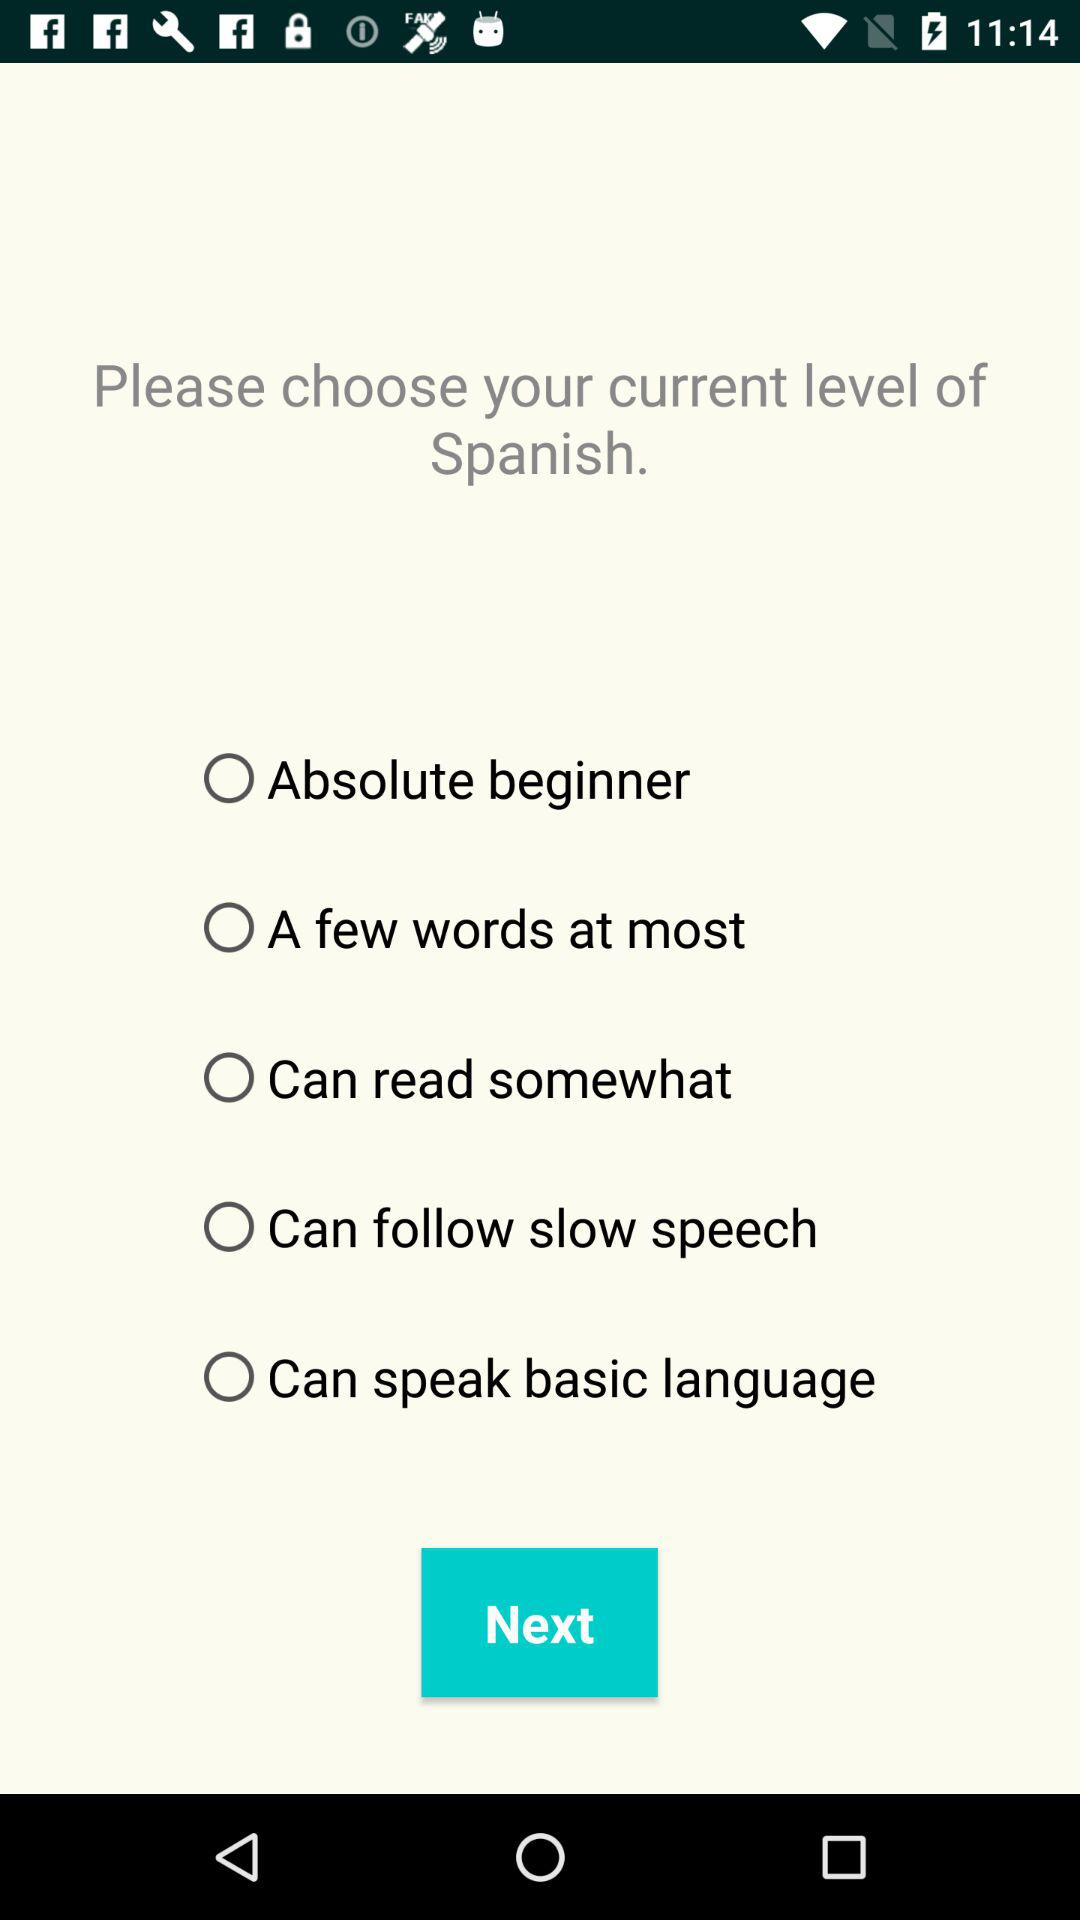How many levels of Spanish proficiency are there?
Answer the question using a single word or phrase. 5 